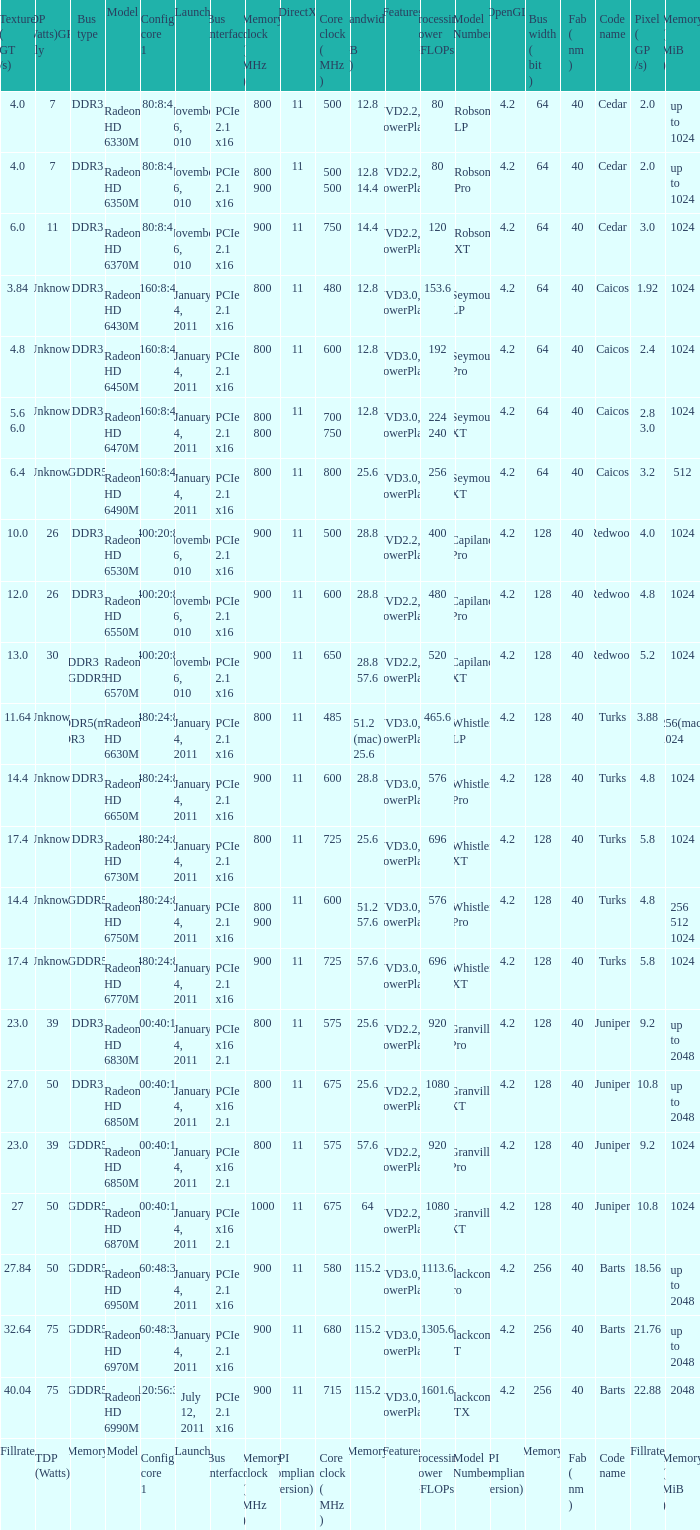What is the value for congi core 1 if the code name is Redwood and core clock(mhz) is 500? 400:20:8. Parse the full table. {'header': ['Texture ( GT /s)', 'TDP (Watts)GPU only', 'Bus type', 'Model', 'Config core 1', 'Launch', 'Bus interface', 'Memory clock ( MHz )', 'DirectX', 'Core clock ( MHz )', 'Bandwidth ( GB /s)', 'Features', 'Processing Power GFLOPs', 'Model Number', 'OpenGL', 'Bus width ( bit )', 'Fab ( nm )', 'Code name', 'Pixel ( GP /s)', 'Memory ( MiB )'], 'rows': [['4.0', '7', 'DDR3', 'Radeon HD 6330M', '80:8:4', 'November 26, 2010', 'PCIe 2.1 x16', '800', '11', '500', '12.8', 'UVD2.2, PowerPlay', '80', 'Robson LP', '4.2', '64', '40', 'Cedar', '2.0', 'up to 1024'], ['4.0', '7', 'DDR3', 'Radeon HD 6350M', '80:8:4', 'November 26, 2010', 'PCIe 2.1 x16', '800 900', '11', '500 500', '12.8 14.4', 'UVD2.2, PowerPlay', '80', 'Robson Pro', '4.2', '64', '40', 'Cedar', '2.0', 'up to 1024'], ['6.0', '11', 'DDR3', 'Radeon HD 6370M', '80:8:4', 'November 26, 2010', 'PCIe 2.1 x16', '900', '11', '750', '14.4', 'UVD2.2, PowerPlay', '120', 'Robson XT', '4.2', '64', '40', 'Cedar', '3.0', '1024'], ['3.84', 'Unknown', 'DDR3', 'Radeon HD 6430M', '160:8:4', 'January 4, 2011', 'PCIe 2.1 x16', '800', '11', '480', '12.8', 'UVD3.0, PowerPlay', '153.6', 'Seymour LP', '4.2', '64', '40', 'Caicos', '1.92', '1024'], ['4.8', 'Unknown', 'DDR3', 'Radeon HD 6450M', '160:8:4', 'January 4, 2011', 'PCIe 2.1 x16', '800', '11', '600', '12.8', 'UVD3.0, PowerPlay', '192', 'Seymour Pro', '4.2', '64', '40', 'Caicos', '2.4', '1024'], ['5.6 6.0', 'Unknown', 'DDR3', 'Radeon HD 6470M', '160:8:4', 'January 4, 2011', 'PCIe 2.1 x16', '800 800', '11', '700 750', '12.8', 'UVD3.0, PowerPlay', '224 240', 'Seymour XT', '4.2', '64', '40', 'Caicos', '2.8 3.0', '1024'], ['6.4', 'Unknown', 'GDDR5', 'Radeon HD 6490M', '160:8:4', 'January 4, 2011', 'PCIe 2.1 x16', '800', '11', '800', '25.6', 'UVD3.0, PowerPlay', '256', 'Seymour XT', '4.2', '64', '40', 'Caicos', '3.2', '512'], ['10.0', '26', 'DDR3', 'Radeon HD 6530M', '400:20:8', 'November 26, 2010', 'PCIe 2.1 x16', '900', '11', '500', '28.8', 'UVD2.2, PowerPlay', '400', 'Capilano Pro', '4.2', '128', '40', 'Redwood', '4.0', '1024'], ['12.0', '26', 'DDR3', 'Radeon HD 6550M', '400:20:8', 'November 26, 2010', 'PCIe 2.1 x16', '900', '11', '600', '28.8', 'UVD2.2, PowerPlay', '480', 'Capilano Pro', '4.2', '128', '40', 'Redwood', '4.8', '1024'], ['13.0', '30', 'DDR3 GDDR5', 'Radeon HD 6570M', '400:20:8', 'November 26, 2010', 'PCIe 2.1 x16', '900', '11', '650', '28.8 57.6', 'UVD2.2, PowerPlay', '520', 'Capilano XT', '4.2', '128', '40', 'Redwood', '5.2', '1024'], ['11.64', 'Unknown', 'GDDR5(mac) DDR3', 'Radeon HD 6630M', '480:24:8', 'January 4, 2011', 'PCIe 2.1 x16', '800', '11', '485', '51.2 (mac) 25.6', 'UVD3.0, PowerPlay', '465.6', 'Whistler LP', '4.2', '128', '40', 'Turks', '3.88', '256(mac) 1024'], ['14.4', 'Unknown', 'DDR3', 'Radeon HD 6650M', '480:24:8', 'January 4, 2011', 'PCIe 2.1 x16', '900', '11', '600', '28.8', 'UVD3.0, PowerPlay', '576', 'Whistler Pro', '4.2', '128', '40', 'Turks', '4.8', '1024'], ['17.4', 'Unknown', 'DDR3', 'Radeon HD 6730M', '480:24:8', 'January 4, 2011', 'PCIe 2.1 x16', '800', '11', '725', '25.6', 'UVD3.0, PowerPlay', '696', 'Whistler XT', '4.2', '128', '40', 'Turks', '5.8', '1024'], ['14.4', 'Unknown', 'GDDR5', 'Radeon HD 6750M', '480:24:8', 'January 4, 2011', 'PCIe 2.1 x16', '800 900', '11', '600', '51.2 57.6', 'UVD3.0, PowerPlay', '576', 'Whistler Pro', '4.2', '128', '40', 'Turks', '4.8', '256 512 1024'], ['17.4', 'Unknown', 'GDDR5', 'Radeon HD 6770M', '480:24:8', 'January 4, 2011', 'PCIe 2.1 x16', '900', '11', '725', '57.6', 'UVD3.0, PowerPlay', '696', 'Whistler XT', '4.2', '128', '40', 'Turks', '5.8', '1024'], ['23.0', '39', 'DDR3', 'Radeon HD 6830M', '800:40:16', 'January 4, 2011', 'PCIe x16 2.1', '800', '11', '575', '25.6', 'UVD2.2, PowerPlay', '920', 'Granville Pro', '4.2', '128', '40', 'Juniper', '9.2', 'up to 2048'], ['27.0', '50', 'DDR3', 'Radeon HD 6850M', '800:40:16', 'January 4, 2011', 'PCIe x16 2.1', '800', '11', '675', '25.6', 'UVD2.2, PowerPlay', '1080', 'Granville XT', '4.2', '128', '40', 'Juniper', '10.8', 'up to 2048'], ['23.0', '39', 'GDDR5', 'Radeon HD 6850M', '800:40:16', 'January 4, 2011', 'PCIe x16 2.1', '800', '11', '575', '57.6', 'UVD2.2, PowerPlay', '920', 'Granville Pro', '4.2', '128', '40', 'Juniper', '9.2', '1024'], ['27', '50', 'GDDR5', 'Radeon HD 6870M', '800:40:16', 'January 4, 2011', 'PCIe x16 2.1', '1000', '11', '675', '64', 'UVD2.2, PowerPlay', '1080', 'Granville XT', '4.2', '128', '40', 'Juniper', '10.8', '1024'], ['27.84', '50', 'GDDR5', 'Radeon HD 6950M', '960:48:32', 'January 4, 2011', 'PCIe 2.1 x16', '900', '11', '580', '115.2', 'UVD3.0, PowerPlay', '1113.6', 'Blackcomb Pro', '4.2', '256', '40', 'Barts', '18.56', 'up to 2048'], ['32.64', '75', 'GDDR5', 'Radeon HD 6970M', '960:48:32', 'January 4, 2011', 'PCIe 2.1 x16', '900', '11', '680', '115.2', 'UVD3.0, PowerPlay', '1305.6', 'Blackcomb XT', '4.2', '256', '40', 'Barts', '21.76', 'up to 2048'], ['40.04', '75', 'GDDR5', 'Radeon HD 6990M', '1120:56:32', 'July 12, 2011', 'PCIe 2.1 x16', '900', '11', '715', '115.2', 'UVD3.0, PowerPlay', '1601.6', 'Blackcomb XTX', '4.2', '256', '40', 'Barts', '22.88', '2048'], ['Fillrate', 'TDP (Watts)', 'Memory', 'Model', 'Config core 1', 'Launch', 'Bus interface', 'Memory clock ( MHz )', 'API compliance (version)', 'Core clock ( MHz )', 'Memory', 'Features', 'Processing Power GFLOPs', 'Model Number', 'API compliance (version)', 'Memory', 'Fab ( nm )', 'Code name', 'Fillrate', 'Memory ( MiB )']]} 